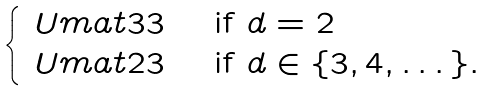Convert formula to latex. <formula><loc_0><loc_0><loc_500><loc_500>\begin{cases} \ U m a t { 3 } { 3 } & \text { if } d = 2 \\ \ U m a t { 2 } { 3 } & \text { if } d \in \{ 3 , 4 , \dots \} . \end{cases}</formula> 